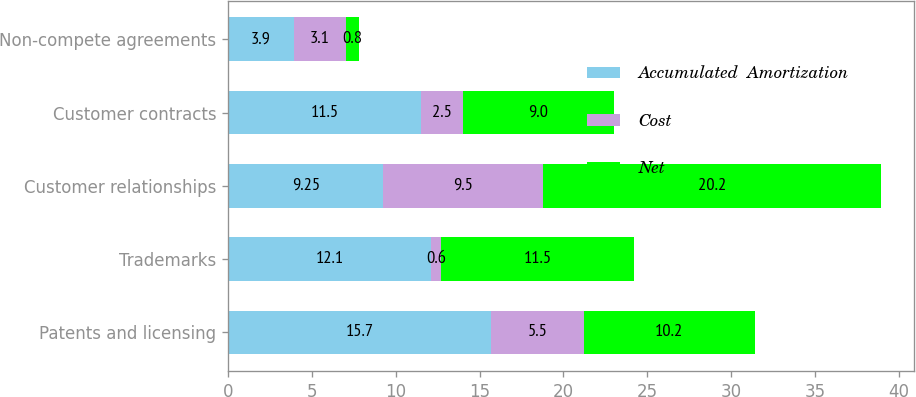Convert chart. <chart><loc_0><loc_0><loc_500><loc_500><stacked_bar_chart><ecel><fcel>Patents and licensing<fcel>Trademarks<fcel>Customer relationships<fcel>Customer contracts<fcel>Non-compete agreements<nl><fcel>Accumulated  Amortization<fcel>15.7<fcel>12.1<fcel>9.25<fcel>11.5<fcel>3.9<nl><fcel>Cost<fcel>5.5<fcel>0.6<fcel>9.5<fcel>2.5<fcel>3.1<nl><fcel>Net<fcel>10.2<fcel>11.5<fcel>20.2<fcel>9<fcel>0.8<nl></chart> 